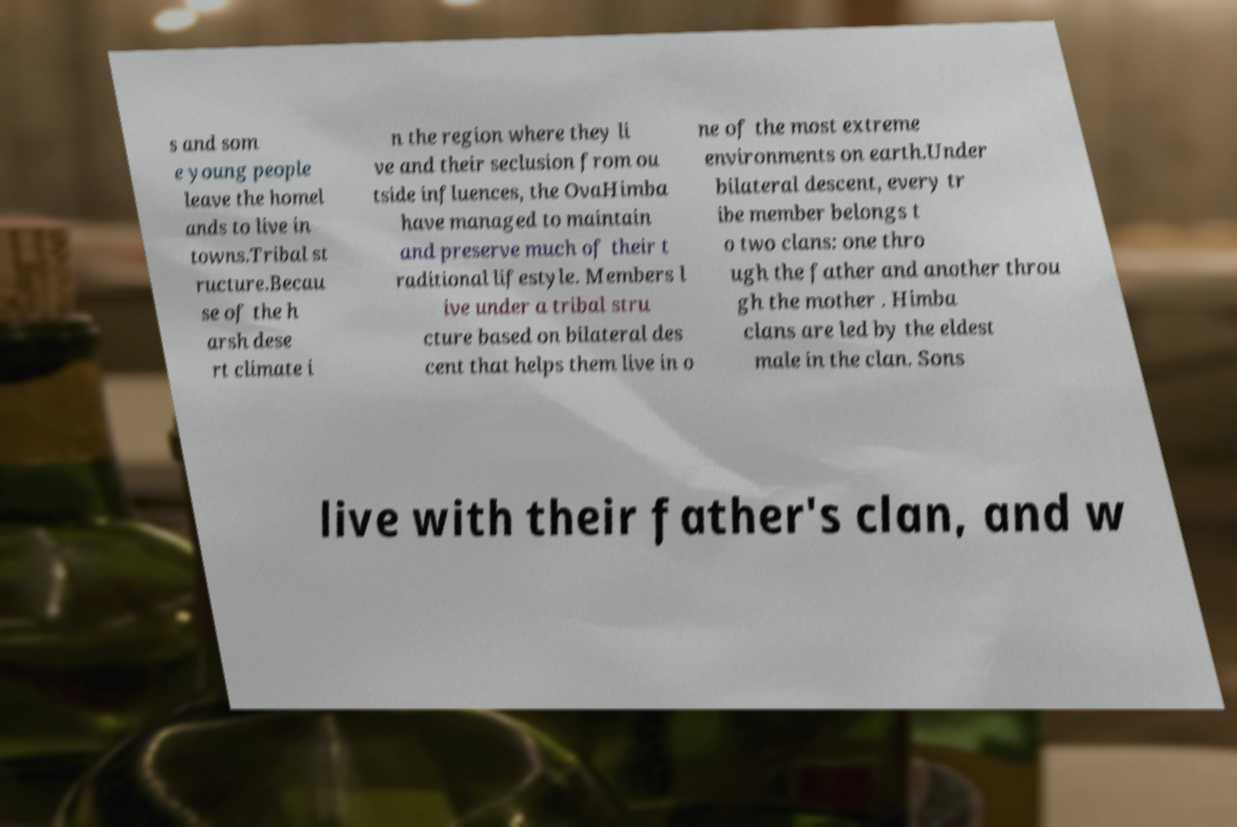Can you accurately transcribe the text from the provided image for me? s and som e young people leave the homel ands to live in towns.Tribal st ructure.Becau se of the h arsh dese rt climate i n the region where they li ve and their seclusion from ou tside influences, the OvaHimba have managed to maintain and preserve much of their t raditional lifestyle. Members l ive under a tribal stru cture based on bilateral des cent that helps them live in o ne of the most extreme environments on earth.Under bilateral descent, every tr ibe member belongs t o two clans: one thro ugh the father and another throu gh the mother . Himba clans are led by the eldest male in the clan. Sons live with their father's clan, and w 